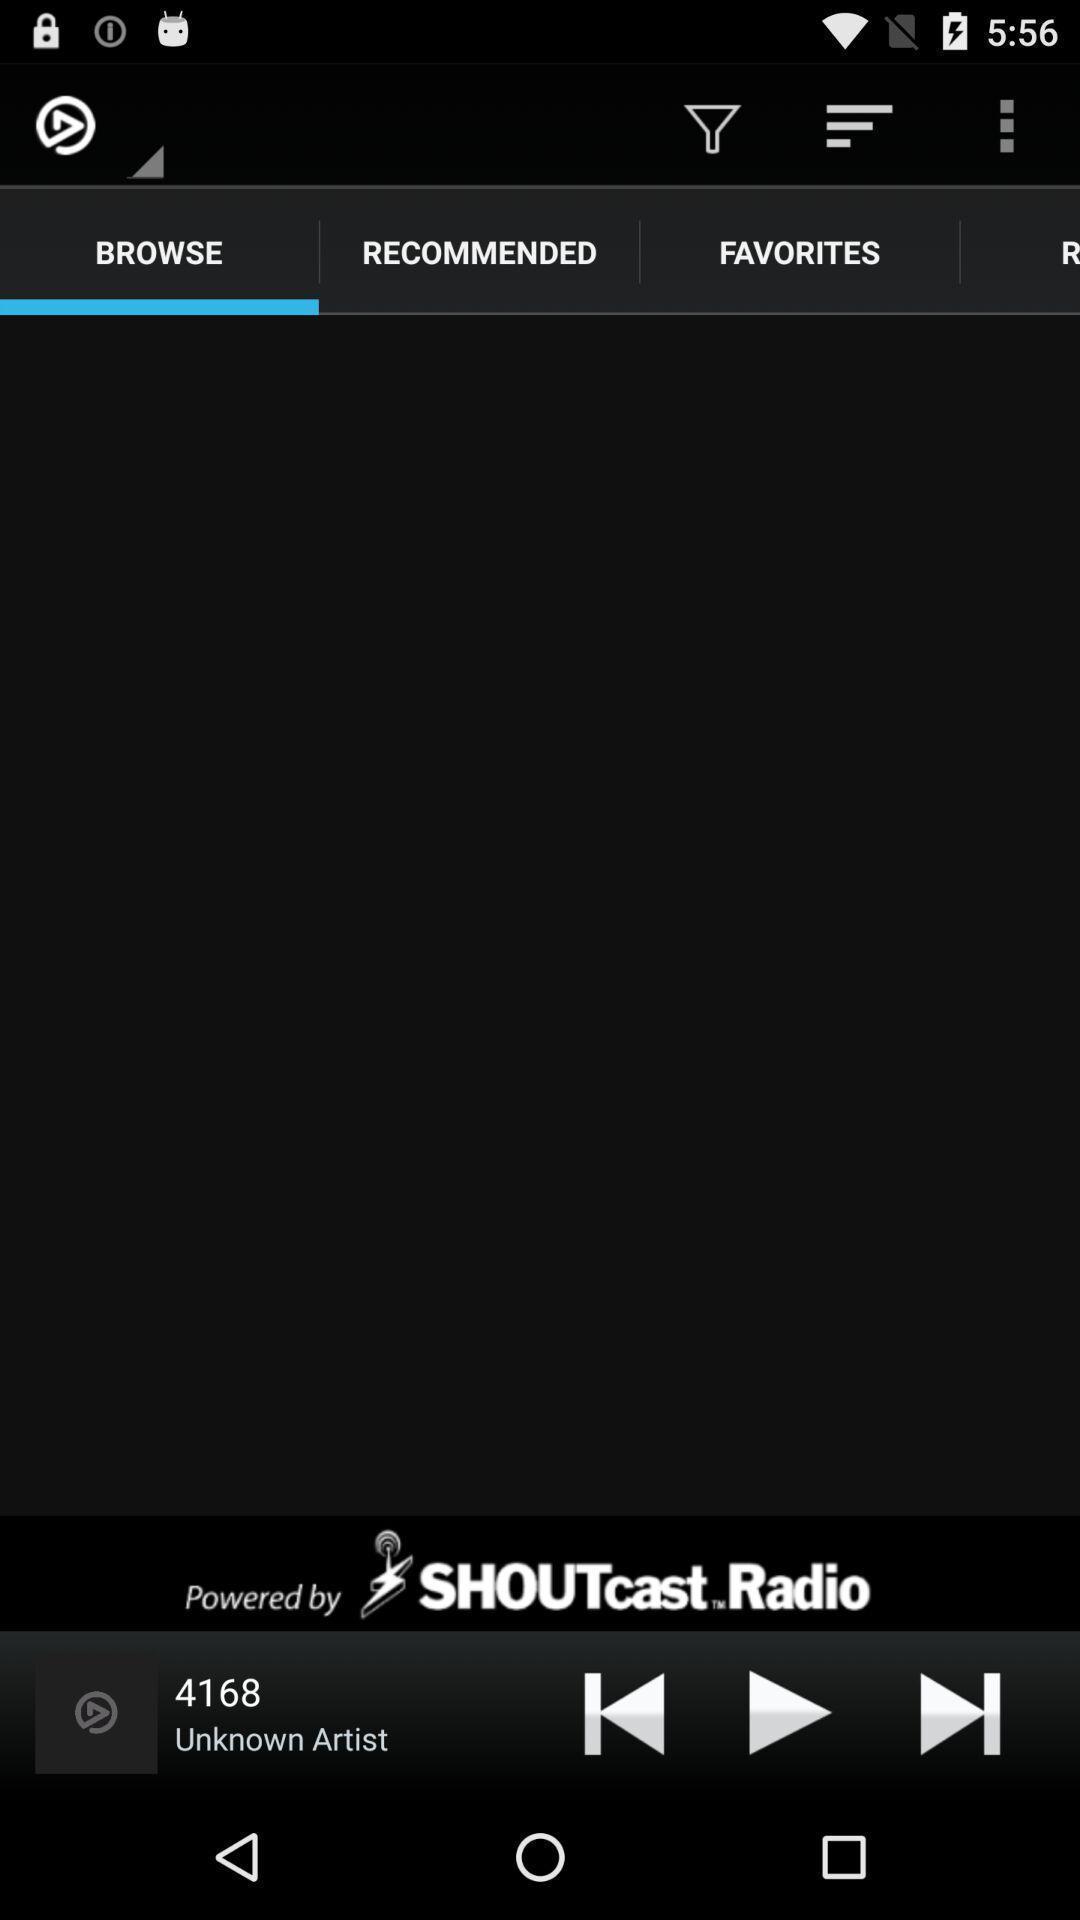Summarize the main components in this picture. Screen page of music player application. 